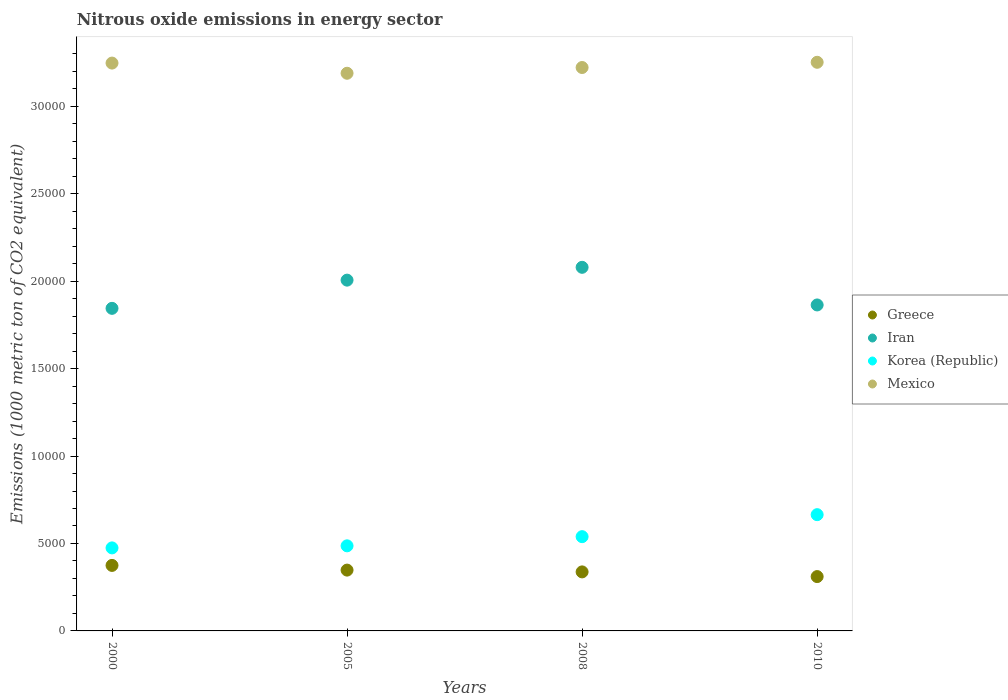How many different coloured dotlines are there?
Your response must be concise. 4. What is the amount of nitrous oxide emitted in Iran in 2010?
Ensure brevity in your answer.  1.86e+04. Across all years, what is the maximum amount of nitrous oxide emitted in Iran?
Your answer should be very brief. 2.08e+04. Across all years, what is the minimum amount of nitrous oxide emitted in Iran?
Provide a short and direct response. 1.84e+04. In which year was the amount of nitrous oxide emitted in Iran minimum?
Your response must be concise. 2000. What is the total amount of nitrous oxide emitted in Mexico in the graph?
Your response must be concise. 1.29e+05. What is the difference between the amount of nitrous oxide emitted in Greece in 2000 and that in 2008?
Your response must be concise. 370.5. What is the difference between the amount of nitrous oxide emitted in Iran in 2005 and the amount of nitrous oxide emitted in Greece in 2010?
Offer a very short reply. 1.69e+04. What is the average amount of nitrous oxide emitted in Korea (Republic) per year?
Make the answer very short. 5412.18. In the year 2005, what is the difference between the amount of nitrous oxide emitted in Korea (Republic) and amount of nitrous oxide emitted in Greece?
Your answer should be compact. 1388. What is the ratio of the amount of nitrous oxide emitted in Korea (Republic) in 2000 to that in 2008?
Make the answer very short. 0.88. What is the difference between the highest and the second highest amount of nitrous oxide emitted in Iran?
Keep it short and to the point. 733.3. What is the difference between the highest and the lowest amount of nitrous oxide emitted in Mexico?
Your response must be concise. 626.9. In how many years, is the amount of nitrous oxide emitted in Mexico greater than the average amount of nitrous oxide emitted in Mexico taken over all years?
Offer a terse response. 2. Is the sum of the amount of nitrous oxide emitted in Greece in 2000 and 2008 greater than the maximum amount of nitrous oxide emitted in Korea (Republic) across all years?
Give a very brief answer. Yes. How many years are there in the graph?
Ensure brevity in your answer.  4. Does the graph contain any zero values?
Ensure brevity in your answer.  No. Where does the legend appear in the graph?
Ensure brevity in your answer.  Center right. How are the legend labels stacked?
Give a very brief answer. Vertical. What is the title of the graph?
Offer a very short reply. Nitrous oxide emissions in energy sector. What is the label or title of the Y-axis?
Provide a succinct answer. Emissions (1000 metric ton of CO2 equivalent). What is the Emissions (1000 metric ton of CO2 equivalent) in Greece in 2000?
Provide a succinct answer. 3745.5. What is the Emissions (1000 metric ton of CO2 equivalent) of Iran in 2000?
Offer a terse response. 1.84e+04. What is the Emissions (1000 metric ton of CO2 equivalent) of Korea (Republic) in 2000?
Provide a succinct answer. 4746.8. What is the Emissions (1000 metric ton of CO2 equivalent) in Mexico in 2000?
Give a very brief answer. 3.25e+04. What is the Emissions (1000 metric ton of CO2 equivalent) of Greece in 2005?
Your answer should be compact. 3477. What is the Emissions (1000 metric ton of CO2 equivalent) of Iran in 2005?
Make the answer very short. 2.01e+04. What is the Emissions (1000 metric ton of CO2 equivalent) in Korea (Republic) in 2005?
Provide a succinct answer. 4865. What is the Emissions (1000 metric ton of CO2 equivalent) of Mexico in 2005?
Make the answer very short. 3.19e+04. What is the Emissions (1000 metric ton of CO2 equivalent) in Greece in 2008?
Make the answer very short. 3375. What is the Emissions (1000 metric ton of CO2 equivalent) in Iran in 2008?
Offer a very short reply. 2.08e+04. What is the Emissions (1000 metric ton of CO2 equivalent) of Korea (Republic) in 2008?
Your answer should be very brief. 5389.6. What is the Emissions (1000 metric ton of CO2 equivalent) of Mexico in 2008?
Give a very brief answer. 3.22e+04. What is the Emissions (1000 metric ton of CO2 equivalent) in Greece in 2010?
Your response must be concise. 3107.1. What is the Emissions (1000 metric ton of CO2 equivalent) of Iran in 2010?
Ensure brevity in your answer.  1.86e+04. What is the Emissions (1000 metric ton of CO2 equivalent) in Korea (Republic) in 2010?
Offer a very short reply. 6647.3. What is the Emissions (1000 metric ton of CO2 equivalent) in Mexico in 2010?
Keep it short and to the point. 3.25e+04. Across all years, what is the maximum Emissions (1000 metric ton of CO2 equivalent) of Greece?
Your answer should be very brief. 3745.5. Across all years, what is the maximum Emissions (1000 metric ton of CO2 equivalent) in Iran?
Your answer should be very brief. 2.08e+04. Across all years, what is the maximum Emissions (1000 metric ton of CO2 equivalent) in Korea (Republic)?
Make the answer very short. 6647.3. Across all years, what is the maximum Emissions (1000 metric ton of CO2 equivalent) of Mexico?
Provide a succinct answer. 3.25e+04. Across all years, what is the minimum Emissions (1000 metric ton of CO2 equivalent) in Greece?
Your response must be concise. 3107.1. Across all years, what is the minimum Emissions (1000 metric ton of CO2 equivalent) of Iran?
Your answer should be compact. 1.84e+04. Across all years, what is the minimum Emissions (1000 metric ton of CO2 equivalent) in Korea (Republic)?
Provide a succinct answer. 4746.8. Across all years, what is the minimum Emissions (1000 metric ton of CO2 equivalent) in Mexico?
Provide a short and direct response. 3.19e+04. What is the total Emissions (1000 metric ton of CO2 equivalent) of Greece in the graph?
Your answer should be compact. 1.37e+04. What is the total Emissions (1000 metric ton of CO2 equivalent) of Iran in the graph?
Provide a short and direct response. 7.79e+04. What is the total Emissions (1000 metric ton of CO2 equivalent) of Korea (Republic) in the graph?
Make the answer very short. 2.16e+04. What is the total Emissions (1000 metric ton of CO2 equivalent) in Mexico in the graph?
Ensure brevity in your answer.  1.29e+05. What is the difference between the Emissions (1000 metric ton of CO2 equivalent) in Greece in 2000 and that in 2005?
Provide a succinct answer. 268.5. What is the difference between the Emissions (1000 metric ton of CO2 equivalent) of Iran in 2000 and that in 2005?
Your answer should be compact. -1612.7. What is the difference between the Emissions (1000 metric ton of CO2 equivalent) in Korea (Republic) in 2000 and that in 2005?
Your answer should be compact. -118.2. What is the difference between the Emissions (1000 metric ton of CO2 equivalent) in Mexico in 2000 and that in 2005?
Keep it short and to the point. 581.7. What is the difference between the Emissions (1000 metric ton of CO2 equivalent) in Greece in 2000 and that in 2008?
Provide a succinct answer. 370.5. What is the difference between the Emissions (1000 metric ton of CO2 equivalent) of Iran in 2000 and that in 2008?
Give a very brief answer. -2346. What is the difference between the Emissions (1000 metric ton of CO2 equivalent) of Korea (Republic) in 2000 and that in 2008?
Keep it short and to the point. -642.8. What is the difference between the Emissions (1000 metric ton of CO2 equivalent) in Mexico in 2000 and that in 2008?
Offer a terse response. 253.5. What is the difference between the Emissions (1000 metric ton of CO2 equivalent) of Greece in 2000 and that in 2010?
Ensure brevity in your answer.  638.4. What is the difference between the Emissions (1000 metric ton of CO2 equivalent) of Iran in 2000 and that in 2010?
Offer a very short reply. -194. What is the difference between the Emissions (1000 metric ton of CO2 equivalent) of Korea (Republic) in 2000 and that in 2010?
Your answer should be compact. -1900.5. What is the difference between the Emissions (1000 metric ton of CO2 equivalent) of Mexico in 2000 and that in 2010?
Keep it short and to the point. -45.2. What is the difference between the Emissions (1000 metric ton of CO2 equivalent) of Greece in 2005 and that in 2008?
Provide a succinct answer. 102. What is the difference between the Emissions (1000 metric ton of CO2 equivalent) of Iran in 2005 and that in 2008?
Provide a short and direct response. -733.3. What is the difference between the Emissions (1000 metric ton of CO2 equivalent) in Korea (Republic) in 2005 and that in 2008?
Provide a succinct answer. -524.6. What is the difference between the Emissions (1000 metric ton of CO2 equivalent) in Mexico in 2005 and that in 2008?
Give a very brief answer. -328.2. What is the difference between the Emissions (1000 metric ton of CO2 equivalent) of Greece in 2005 and that in 2010?
Your answer should be very brief. 369.9. What is the difference between the Emissions (1000 metric ton of CO2 equivalent) in Iran in 2005 and that in 2010?
Provide a succinct answer. 1418.7. What is the difference between the Emissions (1000 metric ton of CO2 equivalent) in Korea (Republic) in 2005 and that in 2010?
Make the answer very short. -1782.3. What is the difference between the Emissions (1000 metric ton of CO2 equivalent) in Mexico in 2005 and that in 2010?
Make the answer very short. -626.9. What is the difference between the Emissions (1000 metric ton of CO2 equivalent) in Greece in 2008 and that in 2010?
Provide a succinct answer. 267.9. What is the difference between the Emissions (1000 metric ton of CO2 equivalent) in Iran in 2008 and that in 2010?
Your answer should be compact. 2152. What is the difference between the Emissions (1000 metric ton of CO2 equivalent) of Korea (Republic) in 2008 and that in 2010?
Your answer should be very brief. -1257.7. What is the difference between the Emissions (1000 metric ton of CO2 equivalent) in Mexico in 2008 and that in 2010?
Make the answer very short. -298.7. What is the difference between the Emissions (1000 metric ton of CO2 equivalent) of Greece in 2000 and the Emissions (1000 metric ton of CO2 equivalent) of Iran in 2005?
Make the answer very short. -1.63e+04. What is the difference between the Emissions (1000 metric ton of CO2 equivalent) in Greece in 2000 and the Emissions (1000 metric ton of CO2 equivalent) in Korea (Republic) in 2005?
Your answer should be compact. -1119.5. What is the difference between the Emissions (1000 metric ton of CO2 equivalent) in Greece in 2000 and the Emissions (1000 metric ton of CO2 equivalent) in Mexico in 2005?
Offer a terse response. -2.81e+04. What is the difference between the Emissions (1000 metric ton of CO2 equivalent) of Iran in 2000 and the Emissions (1000 metric ton of CO2 equivalent) of Korea (Republic) in 2005?
Offer a very short reply. 1.36e+04. What is the difference between the Emissions (1000 metric ton of CO2 equivalent) of Iran in 2000 and the Emissions (1000 metric ton of CO2 equivalent) of Mexico in 2005?
Give a very brief answer. -1.34e+04. What is the difference between the Emissions (1000 metric ton of CO2 equivalent) in Korea (Republic) in 2000 and the Emissions (1000 metric ton of CO2 equivalent) in Mexico in 2005?
Make the answer very short. -2.71e+04. What is the difference between the Emissions (1000 metric ton of CO2 equivalent) of Greece in 2000 and the Emissions (1000 metric ton of CO2 equivalent) of Iran in 2008?
Your answer should be very brief. -1.70e+04. What is the difference between the Emissions (1000 metric ton of CO2 equivalent) in Greece in 2000 and the Emissions (1000 metric ton of CO2 equivalent) in Korea (Republic) in 2008?
Ensure brevity in your answer.  -1644.1. What is the difference between the Emissions (1000 metric ton of CO2 equivalent) in Greece in 2000 and the Emissions (1000 metric ton of CO2 equivalent) in Mexico in 2008?
Your answer should be compact. -2.85e+04. What is the difference between the Emissions (1000 metric ton of CO2 equivalent) of Iran in 2000 and the Emissions (1000 metric ton of CO2 equivalent) of Korea (Republic) in 2008?
Provide a succinct answer. 1.31e+04. What is the difference between the Emissions (1000 metric ton of CO2 equivalent) of Iran in 2000 and the Emissions (1000 metric ton of CO2 equivalent) of Mexico in 2008?
Offer a very short reply. -1.38e+04. What is the difference between the Emissions (1000 metric ton of CO2 equivalent) of Korea (Republic) in 2000 and the Emissions (1000 metric ton of CO2 equivalent) of Mexico in 2008?
Make the answer very short. -2.75e+04. What is the difference between the Emissions (1000 metric ton of CO2 equivalent) in Greece in 2000 and the Emissions (1000 metric ton of CO2 equivalent) in Iran in 2010?
Provide a succinct answer. -1.49e+04. What is the difference between the Emissions (1000 metric ton of CO2 equivalent) in Greece in 2000 and the Emissions (1000 metric ton of CO2 equivalent) in Korea (Republic) in 2010?
Keep it short and to the point. -2901.8. What is the difference between the Emissions (1000 metric ton of CO2 equivalent) of Greece in 2000 and the Emissions (1000 metric ton of CO2 equivalent) of Mexico in 2010?
Give a very brief answer. -2.88e+04. What is the difference between the Emissions (1000 metric ton of CO2 equivalent) in Iran in 2000 and the Emissions (1000 metric ton of CO2 equivalent) in Korea (Republic) in 2010?
Offer a very short reply. 1.18e+04. What is the difference between the Emissions (1000 metric ton of CO2 equivalent) of Iran in 2000 and the Emissions (1000 metric ton of CO2 equivalent) of Mexico in 2010?
Make the answer very short. -1.41e+04. What is the difference between the Emissions (1000 metric ton of CO2 equivalent) in Korea (Republic) in 2000 and the Emissions (1000 metric ton of CO2 equivalent) in Mexico in 2010?
Provide a succinct answer. -2.78e+04. What is the difference between the Emissions (1000 metric ton of CO2 equivalent) of Greece in 2005 and the Emissions (1000 metric ton of CO2 equivalent) of Iran in 2008?
Your response must be concise. -1.73e+04. What is the difference between the Emissions (1000 metric ton of CO2 equivalent) in Greece in 2005 and the Emissions (1000 metric ton of CO2 equivalent) in Korea (Republic) in 2008?
Your answer should be very brief. -1912.6. What is the difference between the Emissions (1000 metric ton of CO2 equivalent) in Greece in 2005 and the Emissions (1000 metric ton of CO2 equivalent) in Mexico in 2008?
Offer a very short reply. -2.87e+04. What is the difference between the Emissions (1000 metric ton of CO2 equivalent) in Iran in 2005 and the Emissions (1000 metric ton of CO2 equivalent) in Korea (Republic) in 2008?
Your response must be concise. 1.47e+04. What is the difference between the Emissions (1000 metric ton of CO2 equivalent) of Iran in 2005 and the Emissions (1000 metric ton of CO2 equivalent) of Mexico in 2008?
Provide a succinct answer. -1.22e+04. What is the difference between the Emissions (1000 metric ton of CO2 equivalent) in Korea (Republic) in 2005 and the Emissions (1000 metric ton of CO2 equivalent) in Mexico in 2008?
Ensure brevity in your answer.  -2.73e+04. What is the difference between the Emissions (1000 metric ton of CO2 equivalent) in Greece in 2005 and the Emissions (1000 metric ton of CO2 equivalent) in Iran in 2010?
Ensure brevity in your answer.  -1.52e+04. What is the difference between the Emissions (1000 metric ton of CO2 equivalent) in Greece in 2005 and the Emissions (1000 metric ton of CO2 equivalent) in Korea (Republic) in 2010?
Offer a very short reply. -3170.3. What is the difference between the Emissions (1000 metric ton of CO2 equivalent) in Greece in 2005 and the Emissions (1000 metric ton of CO2 equivalent) in Mexico in 2010?
Ensure brevity in your answer.  -2.90e+04. What is the difference between the Emissions (1000 metric ton of CO2 equivalent) of Iran in 2005 and the Emissions (1000 metric ton of CO2 equivalent) of Korea (Republic) in 2010?
Offer a very short reply. 1.34e+04. What is the difference between the Emissions (1000 metric ton of CO2 equivalent) in Iran in 2005 and the Emissions (1000 metric ton of CO2 equivalent) in Mexico in 2010?
Your answer should be very brief. -1.25e+04. What is the difference between the Emissions (1000 metric ton of CO2 equivalent) in Korea (Republic) in 2005 and the Emissions (1000 metric ton of CO2 equivalent) in Mexico in 2010?
Provide a succinct answer. -2.76e+04. What is the difference between the Emissions (1000 metric ton of CO2 equivalent) of Greece in 2008 and the Emissions (1000 metric ton of CO2 equivalent) of Iran in 2010?
Your answer should be compact. -1.53e+04. What is the difference between the Emissions (1000 metric ton of CO2 equivalent) of Greece in 2008 and the Emissions (1000 metric ton of CO2 equivalent) of Korea (Republic) in 2010?
Your response must be concise. -3272.3. What is the difference between the Emissions (1000 metric ton of CO2 equivalent) of Greece in 2008 and the Emissions (1000 metric ton of CO2 equivalent) of Mexico in 2010?
Keep it short and to the point. -2.91e+04. What is the difference between the Emissions (1000 metric ton of CO2 equivalent) in Iran in 2008 and the Emissions (1000 metric ton of CO2 equivalent) in Korea (Republic) in 2010?
Make the answer very short. 1.41e+04. What is the difference between the Emissions (1000 metric ton of CO2 equivalent) of Iran in 2008 and the Emissions (1000 metric ton of CO2 equivalent) of Mexico in 2010?
Offer a terse response. -1.17e+04. What is the difference between the Emissions (1000 metric ton of CO2 equivalent) of Korea (Republic) in 2008 and the Emissions (1000 metric ton of CO2 equivalent) of Mexico in 2010?
Give a very brief answer. -2.71e+04. What is the average Emissions (1000 metric ton of CO2 equivalent) of Greece per year?
Your response must be concise. 3426.15. What is the average Emissions (1000 metric ton of CO2 equivalent) of Iran per year?
Provide a short and direct response. 1.95e+04. What is the average Emissions (1000 metric ton of CO2 equivalent) of Korea (Republic) per year?
Give a very brief answer. 5412.18. What is the average Emissions (1000 metric ton of CO2 equivalent) in Mexico per year?
Offer a very short reply. 3.23e+04. In the year 2000, what is the difference between the Emissions (1000 metric ton of CO2 equivalent) of Greece and Emissions (1000 metric ton of CO2 equivalent) of Iran?
Your answer should be very brief. -1.47e+04. In the year 2000, what is the difference between the Emissions (1000 metric ton of CO2 equivalent) of Greece and Emissions (1000 metric ton of CO2 equivalent) of Korea (Republic)?
Offer a terse response. -1001.3. In the year 2000, what is the difference between the Emissions (1000 metric ton of CO2 equivalent) in Greece and Emissions (1000 metric ton of CO2 equivalent) in Mexico?
Your response must be concise. -2.87e+04. In the year 2000, what is the difference between the Emissions (1000 metric ton of CO2 equivalent) in Iran and Emissions (1000 metric ton of CO2 equivalent) in Korea (Republic)?
Your response must be concise. 1.37e+04. In the year 2000, what is the difference between the Emissions (1000 metric ton of CO2 equivalent) of Iran and Emissions (1000 metric ton of CO2 equivalent) of Mexico?
Your answer should be compact. -1.40e+04. In the year 2000, what is the difference between the Emissions (1000 metric ton of CO2 equivalent) in Korea (Republic) and Emissions (1000 metric ton of CO2 equivalent) in Mexico?
Offer a very short reply. -2.77e+04. In the year 2005, what is the difference between the Emissions (1000 metric ton of CO2 equivalent) in Greece and Emissions (1000 metric ton of CO2 equivalent) in Iran?
Provide a succinct answer. -1.66e+04. In the year 2005, what is the difference between the Emissions (1000 metric ton of CO2 equivalent) in Greece and Emissions (1000 metric ton of CO2 equivalent) in Korea (Republic)?
Provide a succinct answer. -1388. In the year 2005, what is the difference between the Emissions (1000 metric ton of CO2 equivalent) of Greece and Emissions (1000 metric ton of CO2 equivalent) of Mexico?
Your answer should be very brief. -2.84e+04. In the year 2005, what is the difference between the Emissions (1000 metric ton of CO2 equivalent) of Iran and Emissions (1000 metric ton of CO2 equivalent) of Korea (Republic)?
Make the answer very short. 1.52e+04. In the year 2005, what is the difference between the Emissions (1000 metric ton of CO2 equivalent) in Iran and Emissions (1000 metric ton of CO2 equivalent) in Mexico?
Give a very brief answer. -1.18e+04. In the year 2005, what is the difference between the Emissions (1000 metric ton of CO2 equivalent) of Korea (Republic) and Emissions (1000 metric ton of CO2 equivalent) of Mexico?
Offer a very short reply. -2.70e+04. In the year 2008, what is the difference between the Emissions (1000 metric ton of CO2 equivalent) of Greece and Emissions (1000 metric ton of CO2 equivalent) of Iran?
Offer a terse response. -1.74e+04. In the year 2008, what is the difference between the Emissions (1000 metric ton of CO2 equivalent) of Greece and Emissions (1000 metric ton of CO2 equivalent) of Korea (Republic)?
Your answer should be very brief. -2014.6. In the year 2008, what is the difference between the Emissions (1000 metric ton of CO2 equivalent) in Greece and Emissions (1000 metric ton of CO2 equivalent) in Mexico?
Make the answer very short. -2.88e+04. In the year 2008, what is the difference between the Emissions (1000 metric ton of CO2 equivalent) in Iran and Emissions (1000 metric ton of CO2 equivalent) in Korea (Republic)?
Your answer should be compact. 1.54e+04. In the year 2008, what is the difference between the Emissions (1000 metric ton of CO2 equivalent) in Iran and Emissions (1000 metric ton of CO2 equivalent) in Mexico?
Your answer should be compact. -1.14e+04. In the year 2008, what is the difference between the Emissions (1000 metric ton of CO2 equivalent) of Korea (Republic) and Emissions (1000 metric ton of CO2 equivalent) of Mexico?
Offer a terse response. -2.68e+04. In the year 2010, what is the difference between the Emissions (1000 metric ton of CO2 equivalent) in Greece and Emissions (1000 metric ton of CO2 equivalent) in Iran?
Make the answer very short. -1.55e+04. In the year 2010, what is the difference between the Emissions (1000 metric ton of CO2 equivalent) in Greece and Emissions (1000 metric ton of CO2 equivalent) in Korea (Republic)?
Offer a terse response. -3540.2. In the year 2010, what is the difference between the Emissions (1000 metric ton of CO2 equivalent) in Greece and Emissions (1000 metric ton of CO2 equivalent) in Mexico?
Keep it short and to the point. -2.94e+04. In the year 2010, what is the difference between the Emissions (1000 metric ton of CO2 equivalent) of Iran and Emissions (1000 metric ton of CO2 equivalent) of Korea (Republic)?
Your answer should be very brief. 1.20e+04. In the year 2010, what is the difference between the Emissions (1000 metric ton of CO2 equivalent) of Iran and Emissions (1000 metric ton of CO2 equivalent) of Mexico?
Provide a succinct answer. -1.39e+04. In the year 2010, what is the difference between the Emissions (1000 metric ton of CO2 equivalent) of Korea (Republic) and Emissions (1000 metric ton of CO2 equivalent) of Mexico?
Ensure brevity in your answer.  -2.59e+04. What is the ratio of the Emissions (1000 metric ton of CO2 equivalent) in Greece in 2000 to that in 2005?
Your answer should be compact. 1.08. What is the ratio of the Emissions (1000 metric ton of CO2 equivalent) in Iran in 2000 to that in 2005?
Your answer should be compact. 0.92. What is the ratio of the Emissions (1000 metric ton of CO2 equivalent) of Korea (Republic) in 2000 to that in 2005?
Offer a very short reply. 0.98. What is the ratio of the Emissions (1000 metric ton of CO2 equivalent) in Mexico in 2000 to that in 2005?
Offer a terse response. 1.02. What is the ratio of the Emissions (1000 metric ton of CO2 equivalent) of Greece in 2000 to that in 2008?
Give a very brief answer. 1.11. What is the ratio of the Emissions (1000 metric ton of CO2 equivalent) of Iran in 2000 to that in 2008?
Keep it short and to the point. 0.89. What is the ratio of the Emissions (1000 metric ton of CO2 equivalent) in Korea (Republic) in 2000 to that in 2008?
Ensure brevity in your answer.  0.88. What is the ratio of the Emissions (1000 metric ton of CO2 equivalent) of Mexico in 2000 to that in 2008?
Ensure brevity in your answer.  1.01. What is the ratio of the Emissions (1000 metric ton of CO2 equivalent) in Greece in 2000 to that in 2010?
Make the answer very short. 1.21. What is the ratio of the Emissions (1000 metric ton of CO2 equivalent) in Korea (Republic) in 2000 to that in 2010?
Offer a terse response. 0.71. What is the ratio of the Emissions (1000 metric ton of CO2 equivalent) of Mexico in 2000 to that in 2010?
Ensure brevity in your answer.  1. What is the ratio of the Emissions (1000 metric ton of CO2 equivalent) in Greece in 2005 to that in 2008?
Your response must be concise. 1.03. What is the ratio of the Emissions (1000 metric ton of CO2 equivalent) of Iran in 2005 to that in 2008?
Your answer should be compact. 0.96. What is the ratio of the Emissions (1000 metric ton of CO2 equivalent) of Korea (Republic) in 2005 to that in 2008?
Keep it short and to the point. 0.9. What is the ratio of the Emissions (1000 metric ton of CO2 equivalent) in Greece in 2005 to that in 2010?
Offer a terse response. 1.12. What is the ratio of the Emissions (1000 metric ton of CO2 equivalent) in Iran in 2005 to that in 2010?
Your answer should be very brief. 1.08. What is the ratio of the Emissions (1000 metric ton of CO2 equivalent) of Korea (Republic) in 2005 to that in 2010?
Give a very brief answer. 0.73. What is the ratio of the Emissions (1000 metric ton of CO2 equivalent) in Mexico in 2005 to that in 2010?
Provide a succinct answer. 0.98. What is the ratio of the Emissions (1000 metric ton of CO2 equivalent) of Greece in 2008 to that in 2010?
Your answer should be very brief. 1.09. What is the ratio of the Emissions (1000 metric ton of CO2 equivalent) of Iran in 2008 to that in 2010?
Provide a succinct answer. 1.12. What is the ratio of the Emissions (1000 metric ton of CO2 equivalent) of Korea (Republic) in 2008 to that in 2010?
Provide a succinct answer. 0.81. What is the difference between the highest and the second highest Emissions (1000 metric ton of CO2 equivalent) in Greece?
Provide a short and direct response. 268.5. What is the difference between the highest and the second highest Emissions (1000 metric ton of CO2 equivalent) of Iran?
Ensure brevity in your answer.  733.3. What is the difference between the highest and the second highest Emissions (1000 metric ton of CO2 equivalent) in Korea (Republic)?
Ensure brevity in your answer.  1257.7. What is the difference between the highest and the second highest Emissions (1000 metric ton of CO2 equivalent) of Mexico?
Give a very brief answer. 45.2. What is the difference between the highest and the lowest Emissions (1000 metric ton of CO2 equivalent) in Greece?
Keep it short and to the point. 638.4. What is the difference between the highest and the lowest Emissions (1000 metric ton of CO2 equivalent) in Iran?
Provide a succinct answer. 2346. What is the difference between the highest and the lowest Emissions (1000 metric ton of CO2 equivalent) in Korea (Republic)?
Give a very brief answer. 1900.5. What is the difference between the highest and the lowest Emissions (1000 metric ton of CO2 equivalent) in Mexico?
Keep it short and to the point. 626.9. 